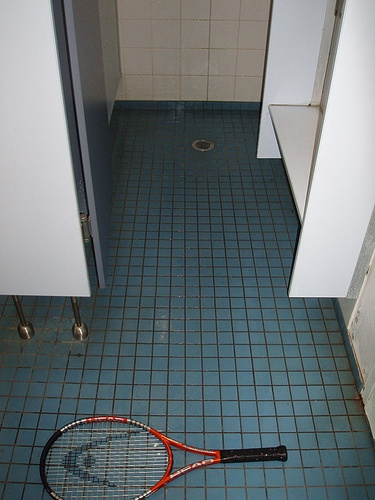Describe the objects in this image and their specific colors. I can see a tennis racket in lightgray, gray, black, blue, and darkgray tones in this image. 